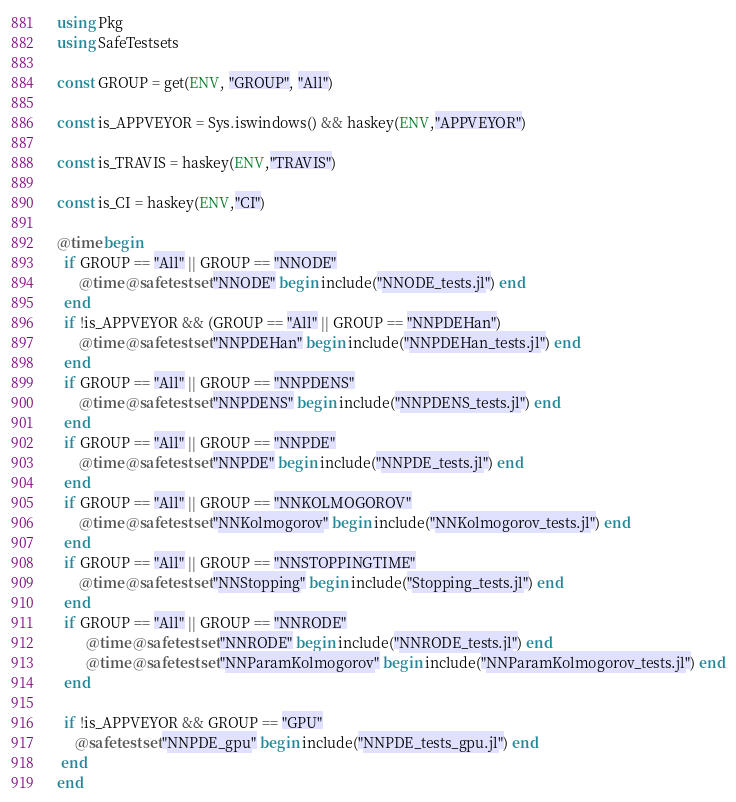<code> <loc_0><loc_0><loc_500><loc_500><_Julia_>using Pkg
using SafeTestsets

const GROUP = get(ENV, "GROUP", "All")

const is_APPVEYOR = Sys.iswindows() && haskey(ENV,"APPVEYOR")

const is_TRAVIS = haskey(ENV,"TRAVIS")

const is_CI = haskey(ENV,"CI")

@time begin
  if GROUP == "All" || GROUP == "NNODE"
      @time @safetestset "NNODE" begin include("NNODE_tests.jl") end
  end
  if !is_APPVEYOR && (GROUP == "All" || GROUP == "NNPDEHan")
      @time @safetestset "NNPDEHan" begin include("NNPDEHan_tests.jl") end
  end
  if GROUP == "All" || GROUP == "NNPDENS"
      @time @safetestset "NNPDENS" begin include("NNPDENS_tests.jl") end
  end
  if GROUP == "All" || GROUP == "NNPDE"
      @time @safetestset "NNPDE" begin include("NNPDE_tests.jl") end
  end
  if GROUP == "All" || GROUP == "NNKOLMOGOROV"
      @time @safetestset "NNKolmogorov" begin include("NNKolmogorov_tests.jl") end
  end
  if GROUP == "All" || GROUP == "NNSTOPPINGTIME"
      @time @safetestset "NNStopping" begin include("Stopping_tests.jl") end
  end
  if GROUP == "All" || GROUP == "NNRODE"
        @time @safetestset "NNRODE" begin include("NNRODE_tests.jl") end
        @time @safetestset "NNParamKolmogorov" begin include("NNParamKolmogorov_tests.jl") end
  end
  
  if !is_APPVEYOR && GROUP == "GPU"
     @safetestset "NNPDE_gpu" begin include("NNPDE_tests_gpu.jl") end
 end
end
</code> 